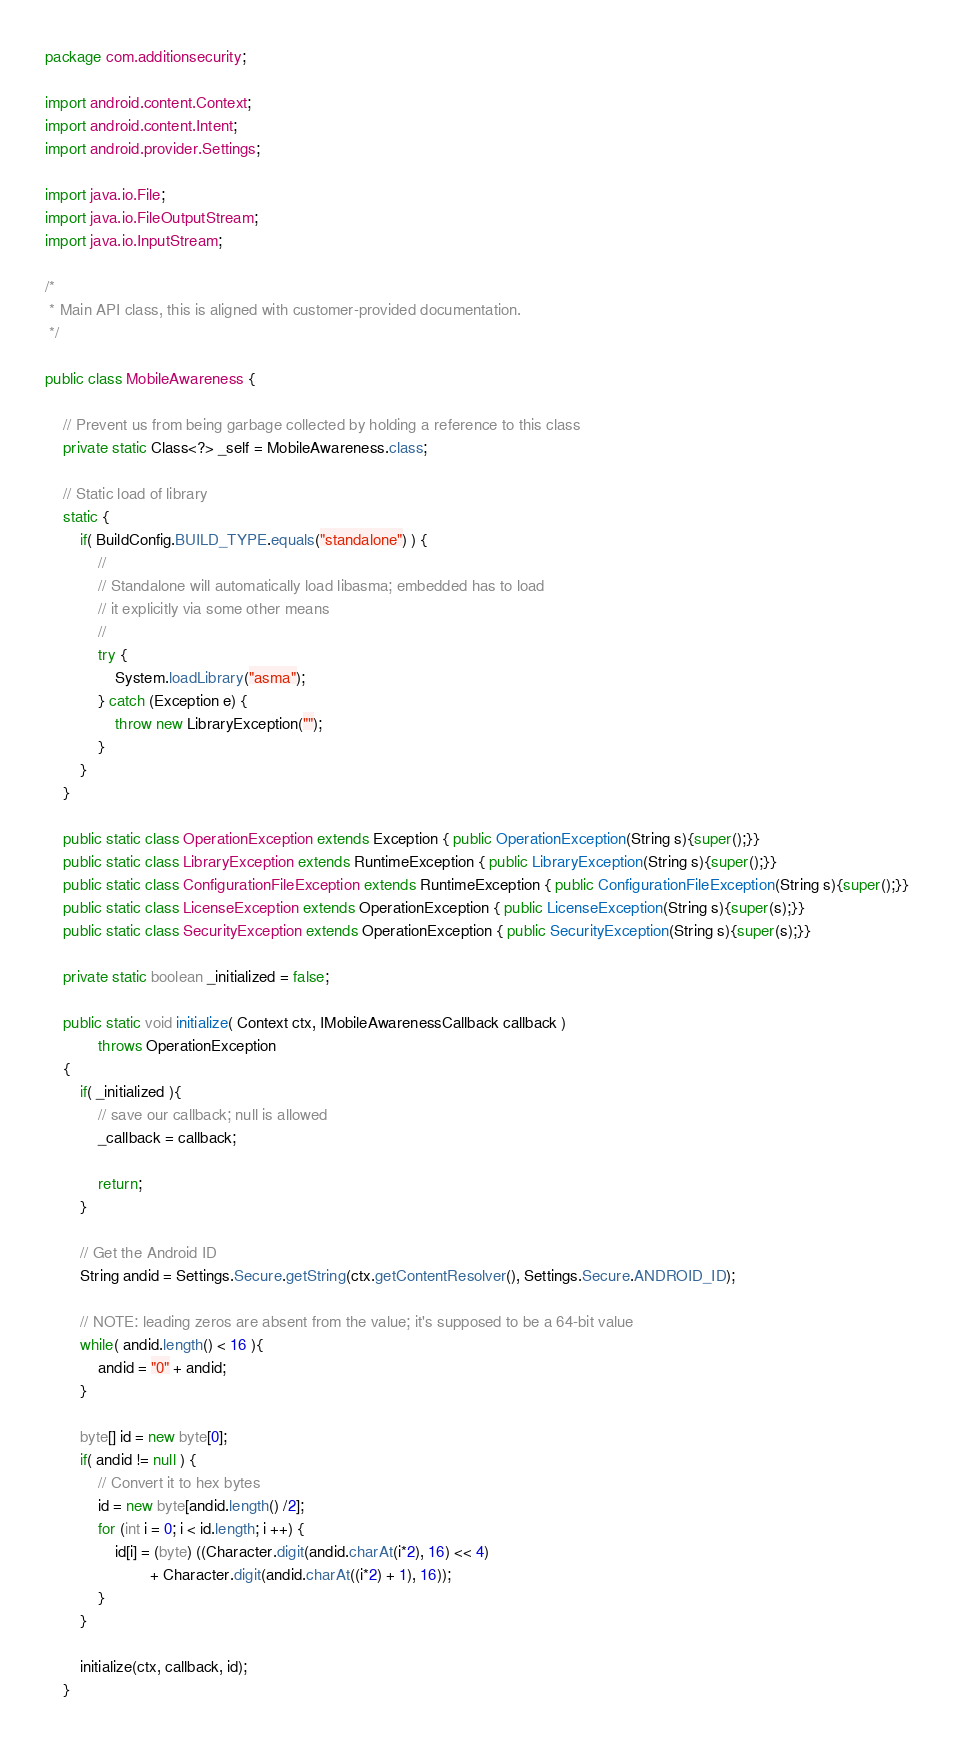Convert code to text. <code><loc_0><loc_0><loc_500><loc_500><_Java_>package com.additionsecurity;

import android.content.Context;
import android.content.Intent;
import android.provider.Settings;

import java.io.File;
import java.io.FileOutputStream;
import java.io.InputStream;

/*
 * Main API class, this is aligned with customer-provided documentation.
 */

public class MobileAwareness {

    // Prevent us from being garbage collected by holding a reference to this class
    private static Class<?> _self = MobileAwareness.class;

    // Static load of library
    static {
        if( BuildConfig.BUILD_TYPE.equals("standalone") ) {
            //
            // Standalone will automatically load libasma; embedded has to load
            // it explicitly via some other means
            //
            try {
                System.loadLibrary("asma");
            } catch (Exception e) {
                throw new LibraryException("");
            }
        }
    }

    public static class OperationException extends Exception { public OperationException(String s){super();}}
    public static class LibraryException extends RuntimeException { public LibraryException(String s){super();}}
    public static class ConfigurationFileException extends RuntimeException { public ConfigurationFileException(String s){super();}}
    public static class LicenseException extends OperationException { public LicenseException(String s){super(s);}}
    public static class SecurityException extends OperationException { public SecurityException(String s){super(s);}}

    private static boolean _initialized = false;

    public static void initialize( Context ctx, IMobileAwarenessCallback callback )
            throws OperationException
    {
        if( _initialized ){
            // save our callback; null is allowed
            _callback = callback;

            return;
        }

        // Get the Android ID
        String andid = Settings.Secure.getString(ctx.getContentResolver(), Settings.Secure.ANDROID_ID);

        // NOTE: leading zeros are absent from the value; it's supposed to be a 64-bit value
        while( andid.length() < 16 ){
            andid = "0" + andid;
        }

        byte[] id = new byte[0];
        if( andid != null ) {
            // Convert it to hex bytes
            id = new byte[andid.length() /2];
            for (int i = 0; i < id.length; i ++) {
                id[i] = (byte) ((Character.digit(andid.charAt(i*2), 16) << 4)
                        + Character.digit(andid.charAt((i*2) + 1), 16));
            }
        }

        initialize(ctx, callback, id);
    }
</code> 